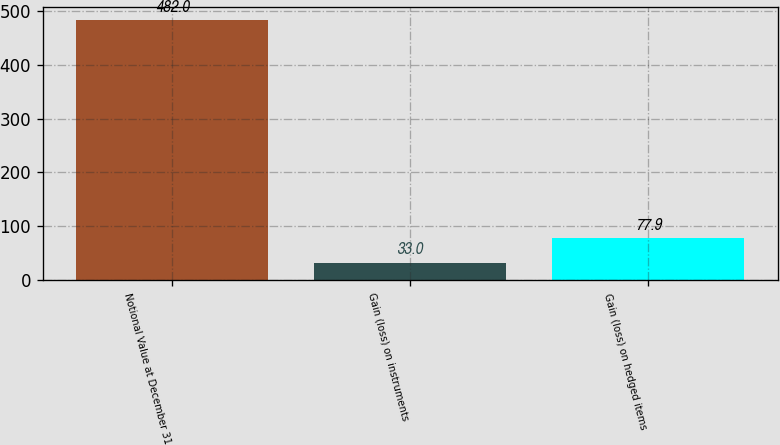Convert chart to OTSL. <chart><loc_0><loc_0><loc_500><loc_500><bar_chart><fcel>Notional Value at December 31<fcel>Gain (loss) on instruments<fcel>Gain (loss) on hedged items<nl><fcel>482<fcel>33<fcel>77.9<nl></chart> 